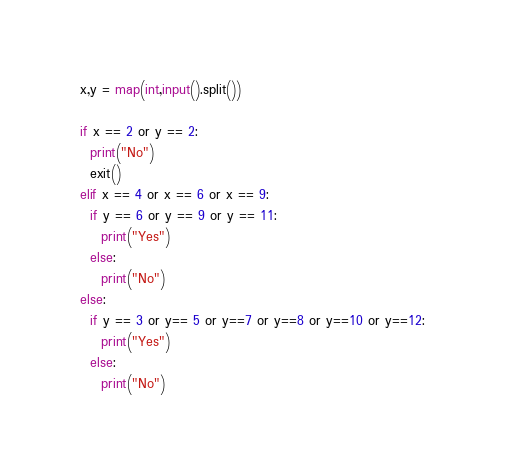Convert code to text. <code><loc_0><loc_0><loc_500><loc_500><_Python_>x,y = map(int,input().split())

if x == 2 or y == 2:
  print("No")
  exit()
elif x == 4 or x == 6 or x == 9:
  if y == 6 or y == 9 or y == 11:
    print("Yes")
  else:
    print("No")
else:
  if y == 3 or y== 5 or y==7 or y==8 or y==10 or y==12:
    print("Yes")
  else:
    print("No")</code> 